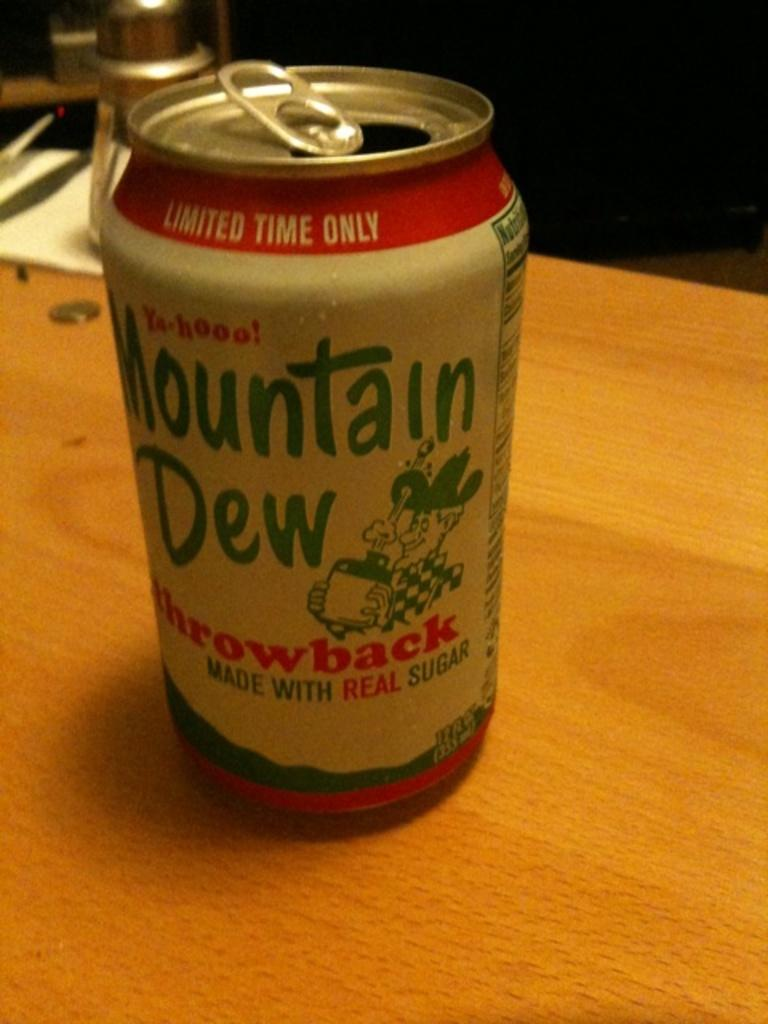<image>
Describe the image concisely. A can of Mountain Dew is a special throwback edition with a retro design. 